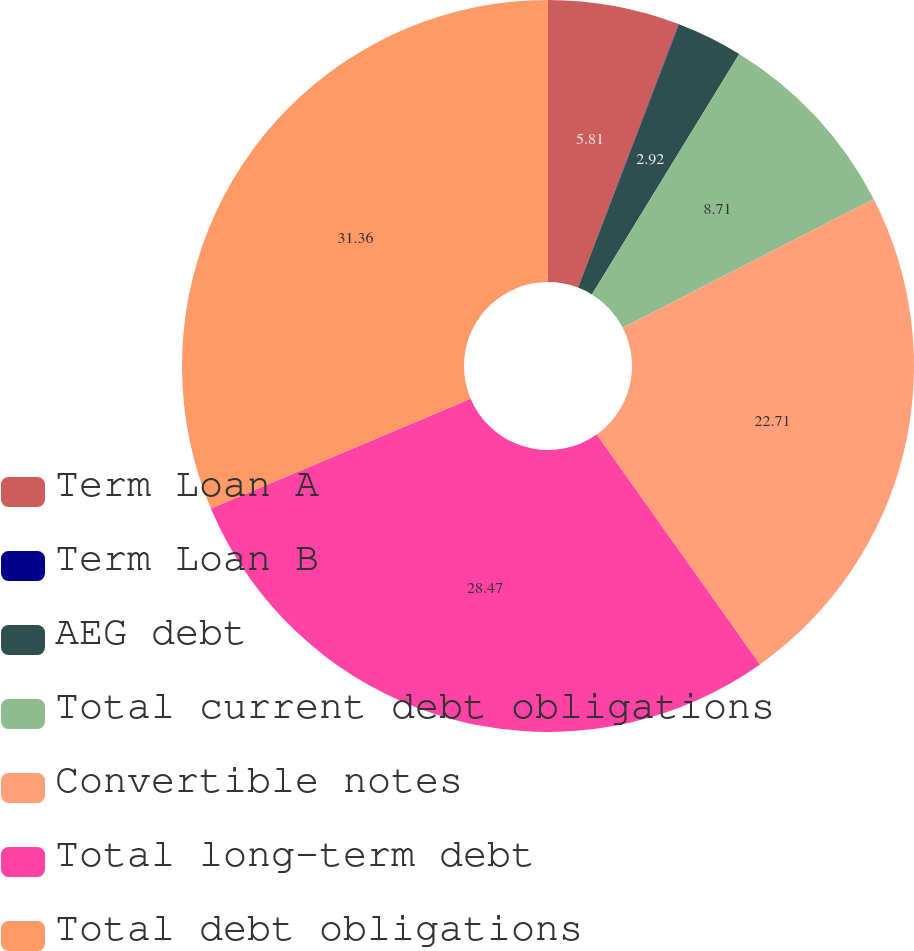Convert chart. <chart><loc_0><loc_0><loc_500><loc_500><pie_chart><fcel>Term Loan A<fcel>Term Loan B<fcel>AEG debt<fcel>Total current debt obligations<fcel>Convertible notes<fcel>Total long-term debt<fcel>Total debt obligations<nl><fcel>5.81%<fcel>0.02%<fcel>2.92%<fcel>8.71%<fcel>22.71%<fcel>28.47%<fcel>31.36%<nl></chart> 